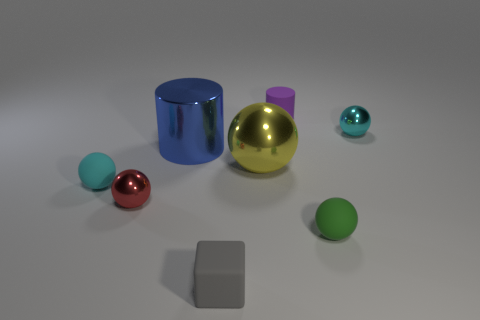What is the color of the other rubber ball that is the same size as the green matte sphere? cyan 